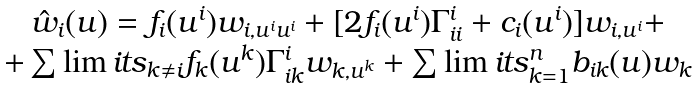Convert formula to latex. <formula><loc_0><loc_0><loc_500><loc_500>\begin{array} { c } \hat { w } _ { i } ( u ) = f _ { i } ( u ^ { i } ) w _ { i , u ^ { i } u ^ { i } } + [ 2 f _ { i } ( u ^ { i } ) \Gamma ^ { i } _ { i i } + c _ { i } ( u ^ { i } ) ] w _ { i , u ^ { i } } + \\ + \sum \lim i t s _ { k \neq i } f _ { k } ( u ^ { k } ) \Gamma ^ { i } _ { i k } w _ { k , u ^ { k } } + \sum \lim i t s _ { k = 1 } ^ { n } b _ { i k } ( u ) w _ { k } \end{array}</formula> 